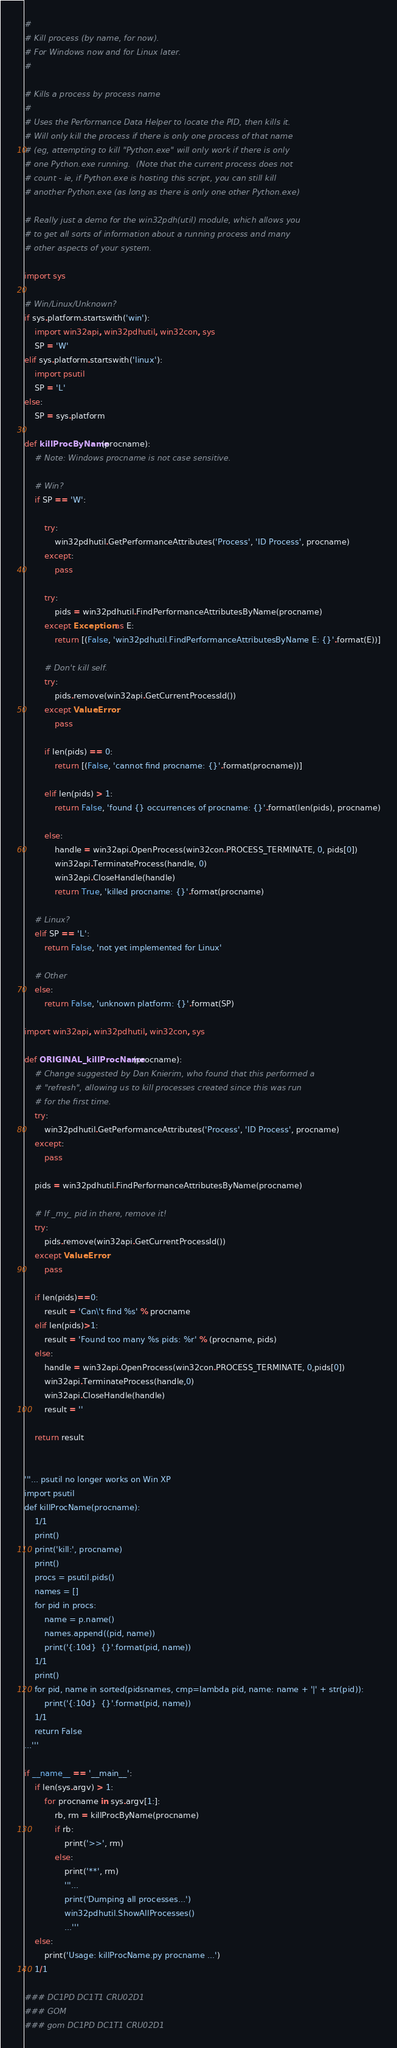<code> <loc_0><loc_0><loc_500><loc_500><_Python_>#
# Kill process (by name, for now).
# For Windows now and for Linux later.
#

# Kills a process by process name
#
# Uses the Performance Data Helper to locate the PID, then kills it.
# Will only kill the process if there is only one process of that name
# (eg, attempting to kill "Python.exe" will only work if there is only
# one Python.exe running.  (Note that the current process does not
# count - ie, if Python.exe is hosting this script, you can still kill
# another Python.exe (as long as there is only one other Python.exe)

# Really just a demo for the win32pdh(util) module, which allows you
# to get all sorts of information about a running process and many
# other aspects of your system.

import sys

# Win/Linux/Unknown?
if sys.platform.startswith('win'):
    import win32api, win32pdhutil, win32con, sys
    SP = 'W'
elif sys.platform.startswith('linux'):
    import psutil
    SP = 'L'
else: 
    SP = sys.platform

def killProcByName(procname):
    # Note: Windows procname is not case sensitive.

    # Win?
    if SP == 'W':

        try:
            win32pdhutil.GetPerformanceAttributes('Process', 'ID Process', procname)
        except:
            pass

        try:
            pids = win32pdhutil.FindPerformanceAttributesByName(procname)
        except Exception as E:
            return [(False, 'win32pdhutil.FindPerformanceAttributesByName E: {}'.format(E))]

        # Don't kill self.
        try:
            pids.remove(win32api.GetCurrentProcessId())
        except ValueError:
            pass

        if len(pids) == 0:
            return [(False, 'cannot find procname: {}'.format(procname))]

        elif len(pids) > 1:
            return False, 'found {} occurrences of procname: {}'.format(len(pids), procname)

        else:
            handle = win32api.OpenProcess(win32con.PROCESS_TERMINATE, 0, pids[0])
            win32api.TerminateProcess(handle, 0)
            win32api.CloseHandle(handle)
            return True, 'killed procname: {}'.format(procname)

    # Linux?
    elif SP == 'L':
        return False, 'not yet implemented for Linux'

    # Other
    else:
        return False, 'unknown platform: {}'.format(SP)

import win32api, win32pdhutil, win32con, sys

def ORIGINAL_killProcName(procname):
	# Change suggested by Dan Knierim, who found that this performed a
	# "refresh", allowing us to kill processes created since this was run
	# for the first time.
	try:
		win32pdhutil.GetPerformanceAttributes('Process', 'ID Process', procname)
	except:
		pass

	pids = win32pdhutil.FindPerformanceAttributesByName(procname)

	# If _my_ pid in there, remove it!
	try:
		pids.remove(win32api.GetCurrentProcessId())
	except ValueError:
		pass

	if len(pids)==0:
		result = 'Can\'t find %s' % procname
	elif len(pids)>1:
		result = 'Found too many %s pids: %r' % (procname, pids)
	else:
		handle = win32api.OpenProcess(win32con.PROCESS_TERMINATE, 0,pids[0])
		win32api.TerminateProcess(handle,0)
		win32api.CloseHandle(handle)
		result = ''

	return result


'''... psutil no longer works on Win XP
import psutil
def killProcName(procname):
    1/1
    print()
    print('kill:', procname)
    print()
    procs = psutil.pids()
    names = []
    for pid in procs:
        name = p.name()
        names.append((pid, name))
        print('{:10d}  {}'.format(pid, name))
    1/1
    print()
    for pid, name in sorted(pidsnames, cmp=lambda pid, name: name + '|' + str(pid)):
        print('{:10d}  {}'.format(pid, name))
    1/1
    return False
...'''

if __name__ == '__main__':
    if len(sys.argv) > 1:
        for procname in sys.argv[1:]:
            rb, rm = killProcByName(procname)
            if rb:
                print('>>', rm)
            else:
                print('**', rm)
                '''...
                print('Dumping all processes...')
                win32pdhutil.ShowAllProcesses()
                ...'''
    else:
        print('Usage: killProcName.py procname ...')
    1/1

### DC1PD DC1T1 CRU02D1
### GOM
### gom DC1PD DC1T1 CRU02D1
</code> 